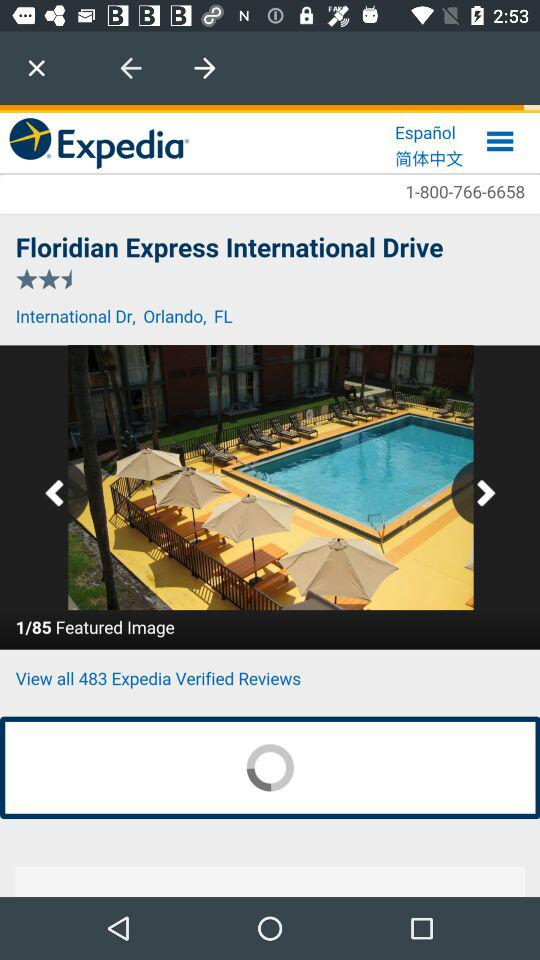At which county hotel is present?
When the provided information is insufficient, respond with <no answer>. <no answer> 